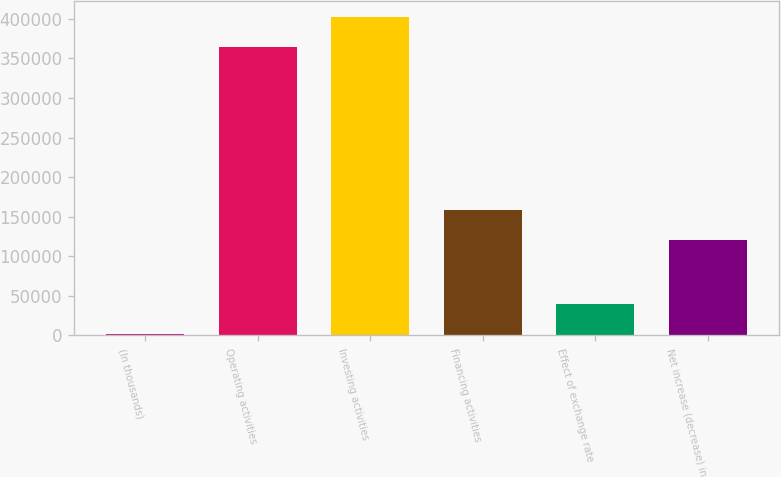<chart> <loc_0><loc_0><loc_500><loc_500><bar_chart><fcel>(In thousands)<fcel>Operating activities<fcel>Investing activities<fcel>Financing activities<fcel>Effect of exchange rate<fcel>Net increase (decrease) in<nl><fcel>2016<fcel>364368<fcel>402280<fcel>158530<fcel>39928.3<fcel>120618<nl></chart> 